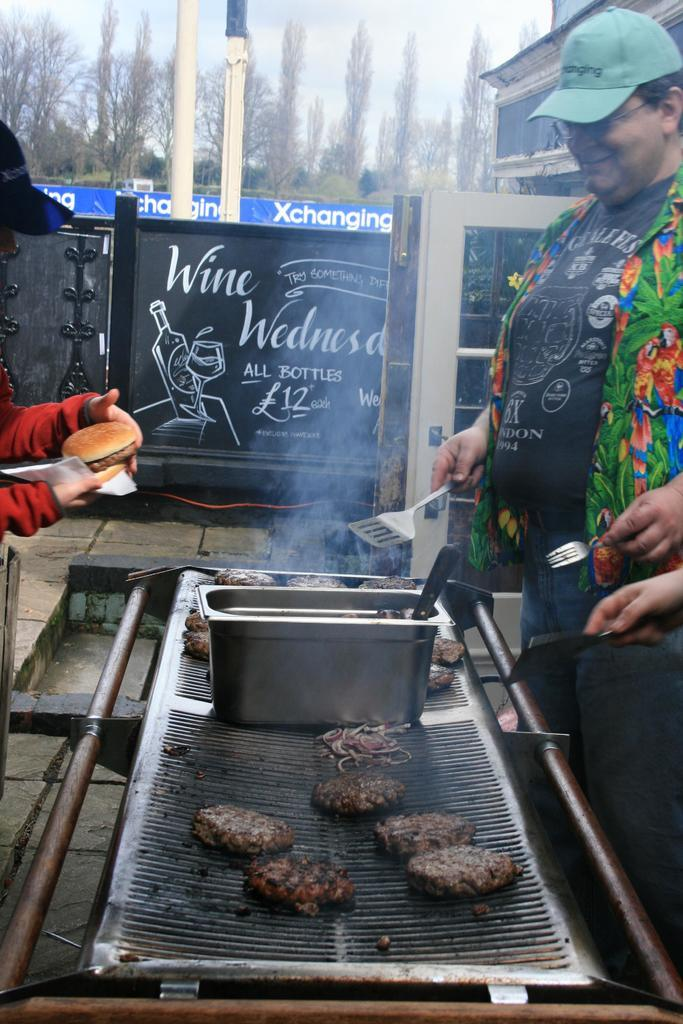<image>
Relay a brief, clear account of the picture shown. a man cooking burgers on a grill with a sign reading 'wine wednesday' 